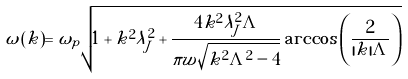Convert formula to latex. <formula><loc_0><loc_0><loc_500><loc_500>\omega ( k ) = \omega _ { p } \sqrt { 1 + k ^ { 2 } \lambda _ { J } ^ { 2 } + \frac { 4 k ^ { 2 } \lambda _ { J } ^ { 2 } \Lambda } { \pi w \sqrt { k ^ { 2 } \Lambda ^ { 2 } - 4 } } \arccos \left ( \frac { 2 } { | k | \Lambda } \right ) }</formula> 